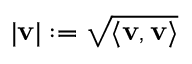<formula> <loc_0><loc_0><loc_500><loc_500>| v | \colon = { \sqrt { \langle v , v \rangle } }</formula> 